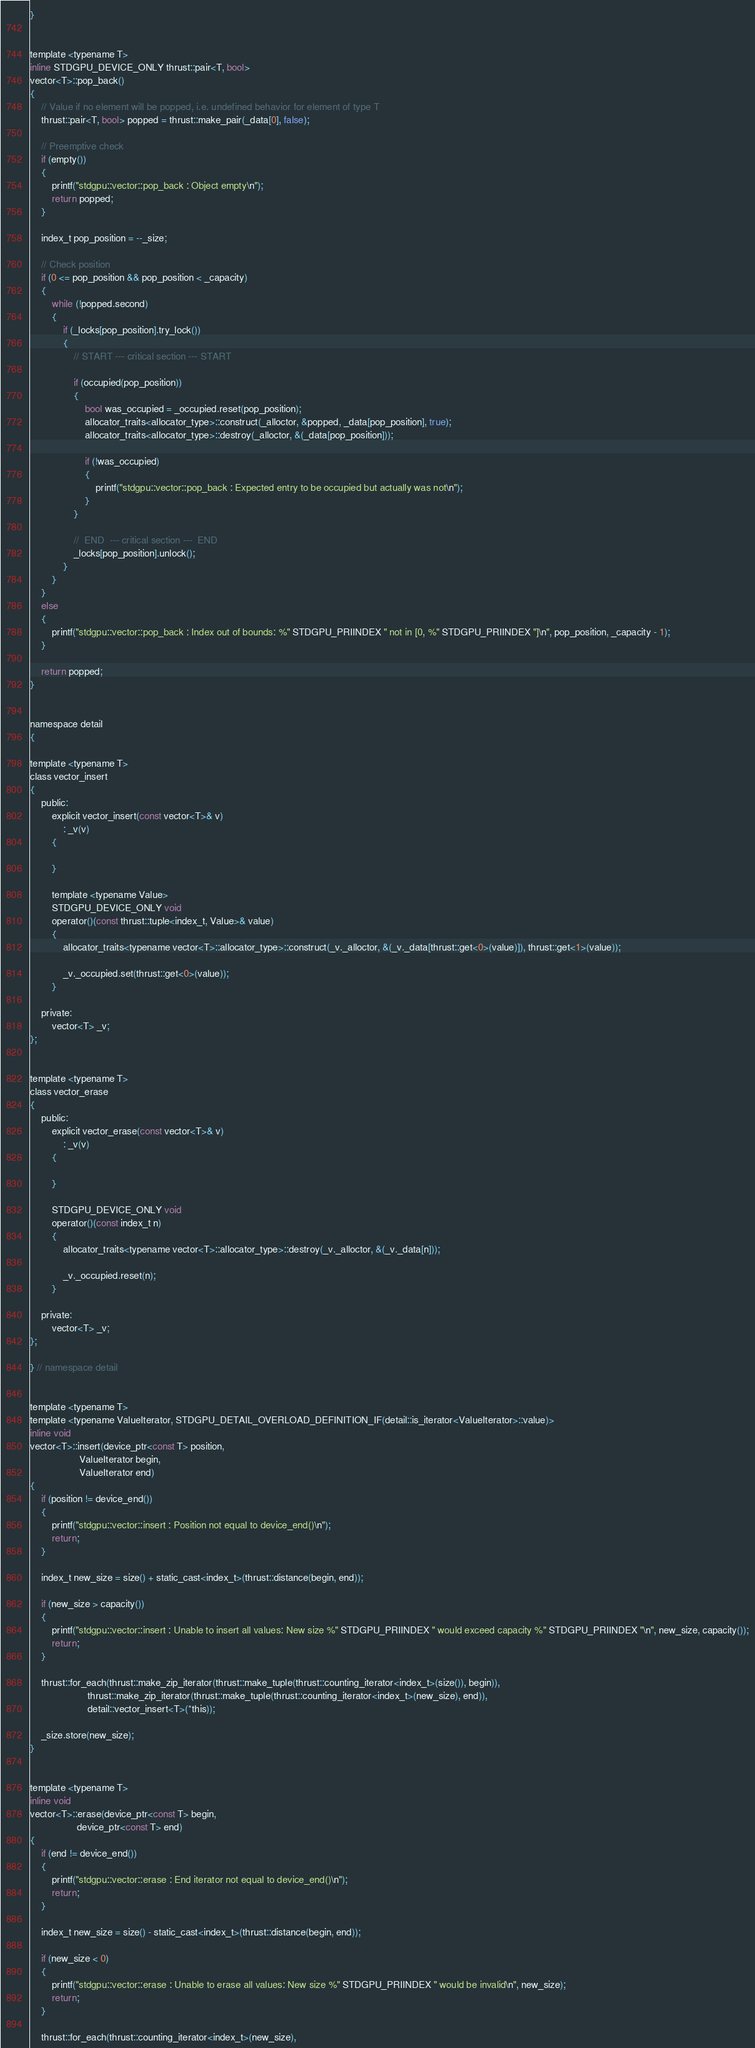<code> <loc_0><loc_0><loc_500><loc_500><_Cuda_>}


template <typename T>
inline STDGPU_DEVICE_ONLY thrust::pair<T, bool>
vector<T>::pop_back()
{
    // Value if no element will be popped, i.e. undefined behavior for element of type T
    thrust::pair<T, bool> popped = thrust::make_pair(_data[0], false);

    // Preemptive check
    if (empty())
    {
        printf("stdgpu::vector::pop_back : Object empty\n");
        return popped;
    }

    index_t pop_position = --_size;

    // Check position
    if (0 <= pop_position && pop_position < _capacity)
    {
        while (!popped.second)
        {
            if (_locks[pop_position].try_lock())
            {
                // START --- critical section --- START

                if (occupied(pop_position))
                {
                    bool was_occupied = _occupied.reset(pop_position);
                    allocator_traits<allocator_type>::construct(_alloctor, &popped, _data[pop_position], true);
                    allocator_traits<allocator_type>::destroy(_alloctor, &(_data[pop_position]));

                    if (!was_occupied)
                    {
                        printf("stdgpu::vector::pop_back : Expected entry to be occupied but actually was not\n");
                    }
                }

                //  END  --- critical section ---  END
                _locks[pop_position].unlock();
            }
        }
    }
    else
    {
        printf("stdgpu::vector::pop_back : Index out of bounds: %" STDGPU_PRIINDEX " not in [0, %" STDGPU_PRIINDEX "]\n", pop_position, _capacity - 1);
    }

    return popped;
}


namespace detail
{

template <typename T>
class vector_insert
{
    public:
        explicit vector_insert(const vector<T>& v)
            : _v(v)
        {

        }

        template <typename Value>
        STDGPU_DEVICE_ONLY void
        operator()(const thrust::tuple<index_t, Value>& value)
        {
            allocator_traits<typename vector<T>::allocator_type>::construct(_v._alloctor, &(_v._data[thrust::get<0>(value)]), thrust::get<1>(value));

            _v._occupied.set(thrust::get<0>(value));
        }

    private:
        vector<T> _v;
};


template <typename T>
class vector_erase
{
    public:
        explicit vector_erase(const vector<T>& v)
            : _v(v)
        {

        }

        STDGPU_DEVICE_ONLY void
        operator()(const index_t n)
        {
            allocator_traits<typename vector<T>::allocator_type>::destroy(_v._alloctor, &(_v._data[n]));

            _v._occupied.reset(n);
        }

    private:
        vector<T> _v;
};

} // namespace detail


template <typename T>
template <typename ValueIterator, STDGPU_DETAIL_OVERLOAD_DEFINITION_IF(detail::is_iterator<ValueIterator>::value)>
inline void
vector<T>::insert(device_ptr<const T> position,
                  ValueIterator begin,
                  ValueIterator end)
{
    if (position != device_end())
    {
        printf("stdgpu::vector::insert : Position not equal to device_end()\n");
        return;
    }

    index_t new_size = size() + static_cast<index_t>(thrust::distance(begin, end));

    if (new_size > capacity())
    {
        printf("stdgpu::vector::insert : Unable to insert all values: New size %" STDGPU_PRIINDEX " would exceed capacity %" STDGPU_PRIINDEX "\n", new_size, capacity());
        return;
    }

    thrust::for_each(thrust::make_zip_iterator(thrust::make_tuple(thrust::counting_iterator<index_t>(size()), begin)),
                     thrust::make_zip_iterator(thrust::make_tuple(thrust::counting_iterator<index_t>(new_size), end)),
                     detail::vector_insert<T>(*this));

    _size.store(new_size);
}


template <typename T>
inline void
vector<T>::erase(device_ptr<const T> begin,
                 device_ptr<const T> end)
{
    if (end != device_end())
    {
        printf("stdgpu::vector::erase : End iterator not equal to device_end()\n");
        return;
    }

    index_t new_size = size() - static_cast<index_t>(thrust::distance(begin, end));

    if (new_size < 0)
    {
        printf("stdgpu::vector::erase : Unable to erase all values: New size %" STDGPU_PRIINDEX " would be invalid\n", new_size);
        return;
    }

    thrust::for_each(thrust::counting_iterator<index_t>(new_size),</code> 